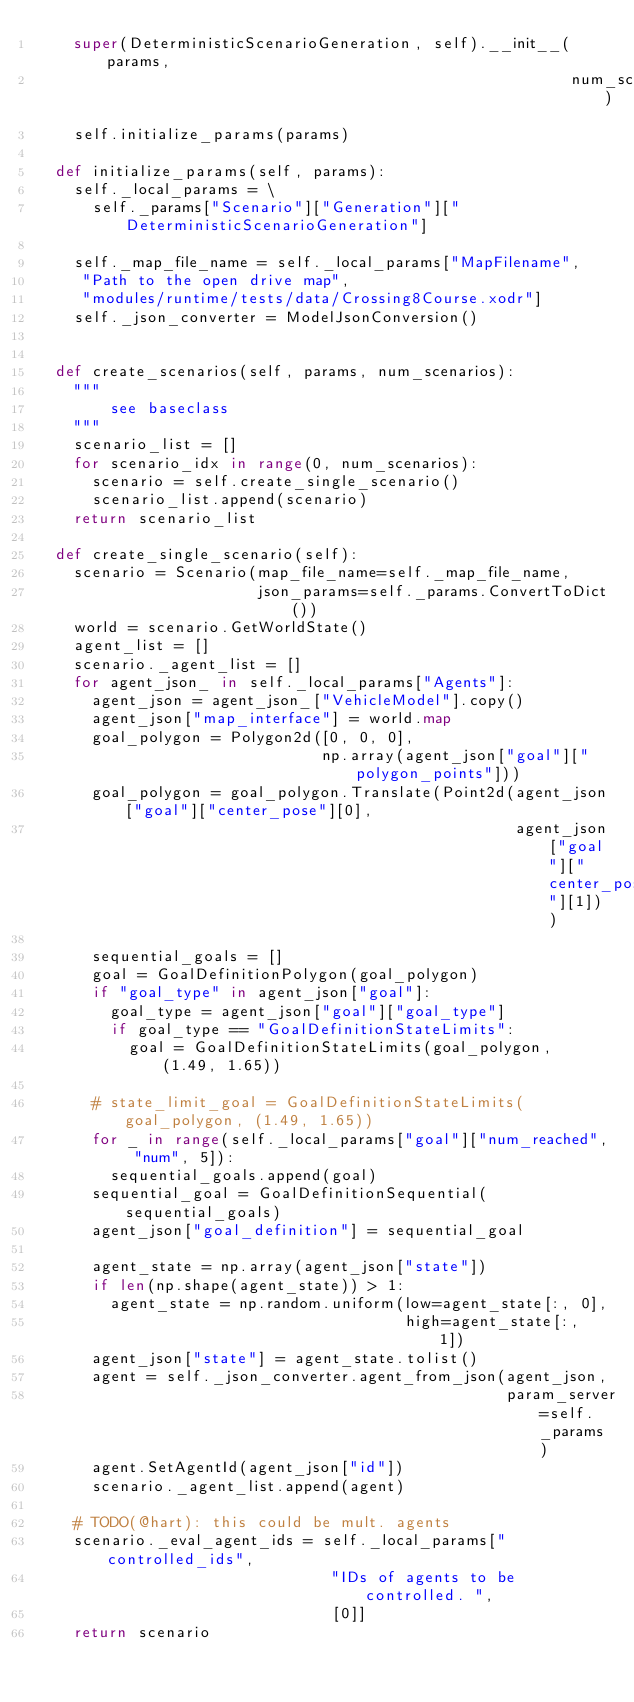<code> <loc_0><loc_0><loc_500><loc_500><_Python_>    super(DeterministicScenarioGeneration, self).__init__(params,
                                                          num_scenarios)
    self.initialize_params(params)

  def initialize_params(self, params):
    self._local_params = \
      self._params["Scenario"]["Generation"]["DeterministicScenarioGeneration"]
    
    self._map_file_name = self._local_params["MapFilename",
     "Path to the open drive map", 
     "modules/runtime/tests/data/Crossing8Course.xodr"]
    self._json_converter = ModelJsonConversion()


  def create_scenarios(self, params, num_scenarios):
    """ 
        see baseclass
    """
    scenario_list = []
    for scenario_idx in range(0, num_scenarios):
      scenario = self.create_single_scenario()     
      scenario_list.append(scenario)
    return scenario_list

  def create_single_scenario(self):
    scenario = Scenario(map_file_name=self._map_file_name,
                        json_params=self._params.ConvertToDict())
    world = scenario.GetWorldState()
    agent_list = []
    scenario._agent_list = []
    for agent_json_ in self._local_params["Agents"]:
      agent_json = agent_json_["VehicleModel"].copy()
      agent_json["map_interface"] = world.map
      goal_polygon = Polygon2d([0, 0, 0],
                               np.array(agent_json["goal"]["polygon_points"]))
      goal_polygon = goal_polygon.Translate(Point2d(agent_json["goal"]["center_pose"][0],
                                                    agent_json["goal"]["center_pose"][1]))

      sequential_goals = []
      goal = GoalDefinitionPolygon(goal_polygon)
      if "goal_type" in agent_json["goal"]:
        goal_type = agent_json["goal"]["goal_type"]
        if goal_type == "GoalDefinitionStateLimits":
          goal = GoalDefinitionStateLimits(goal_polygon, (1.49, 1.65))

      # state_limit_goal = GoalDefinitionStateLimits(goal_polygon, (1.49, 1.65))
      for _ in range(self._local_params["goal"]["num_reached", "num", 5]):
        sequential_goals.append(goal)
      sequential_goal = GoalDefinitionSequential(sequential_goals)
      agent_json["goal_definition"] = sequential_goal

      agent_state = np.array(agent_json["state"])
      if len(np.shape(agent_state)) > 1:
        agent_state = np.random.uniform(low=agent_state[:, 0],
                                        high=agent_state[:, 1])
      agent_json["state"] = agent_state.tolist()
      agent = self._json_converter.agent_from_json(agent_json,
                                                   param_server=self._params)
      agent.SetAgentId(agent_json["id"])
      scenario._agent_list.append(agent)
    
    # TODO(@hart): this could be mult. agents
    scenario._eval_agent_ids = self._local_params["controlled_ids",
                                "IDs of agents to be controlled. ",
                                [0]]
    return scenario</code> 